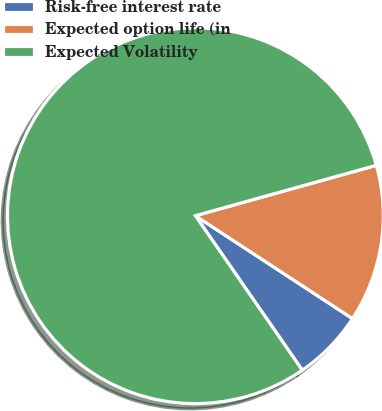<chart> <loc_0><loc_0><loc_500><loc_500><pie_chart><fcel>Risk-free interest rate<fcel>Expected option life (in<fcel>Expected Volatility<nl><fcel>6.14%<fcel>13.55%<fcel>80.31%<nl></chart> 